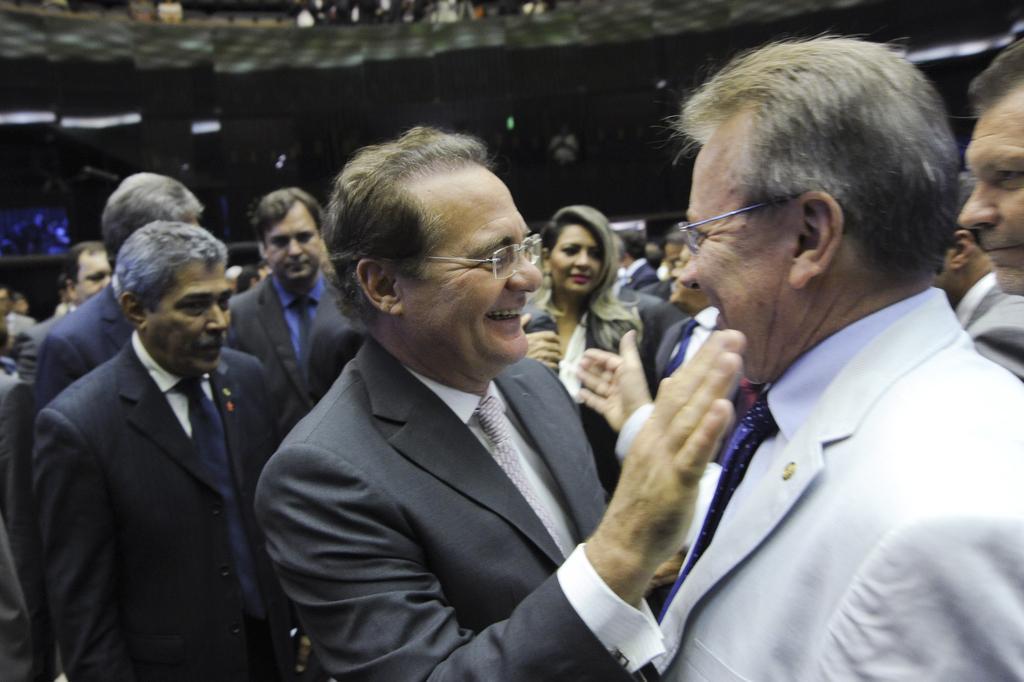Describe this image in one or two sentences. In this image, we can see a group of people. Here a person is smiling. Background there is a blur view. 